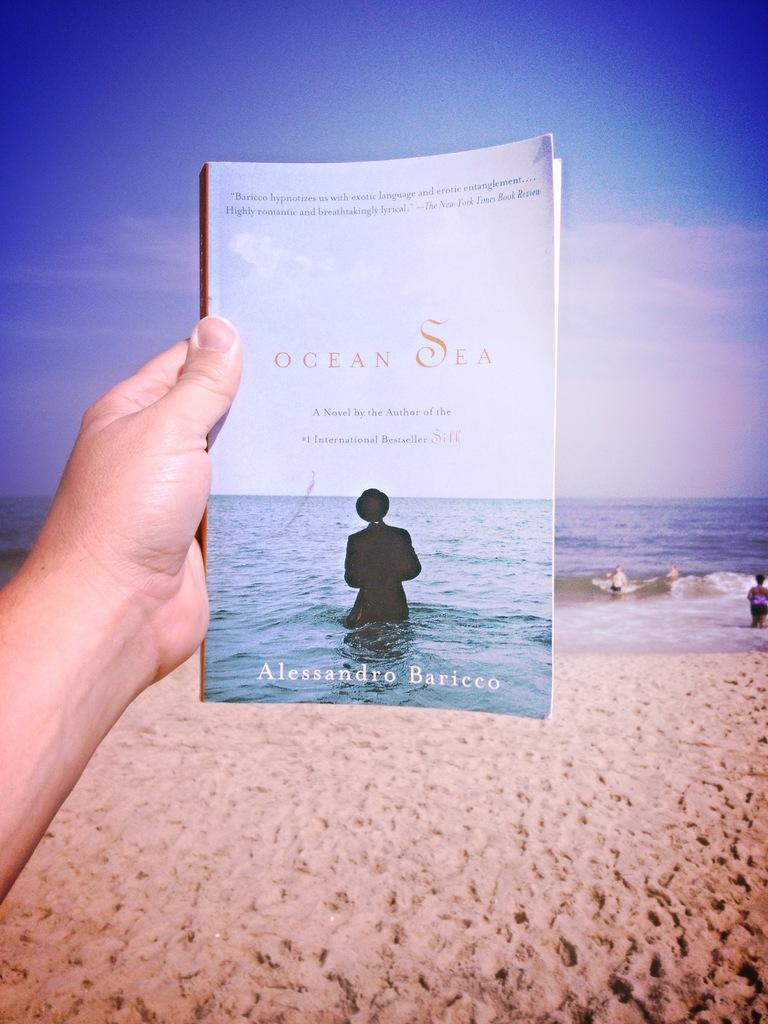What is the person in the image holding? The person is holding a book in the image. Where is the person located in the image? The person is on the left side of the image. What can be seen in the background of the image? There is water and clouds in the sky visible in the background of the image. What type of quill is the person using to write in the book? There is no quill present in the image; the person is not writing in the book. 